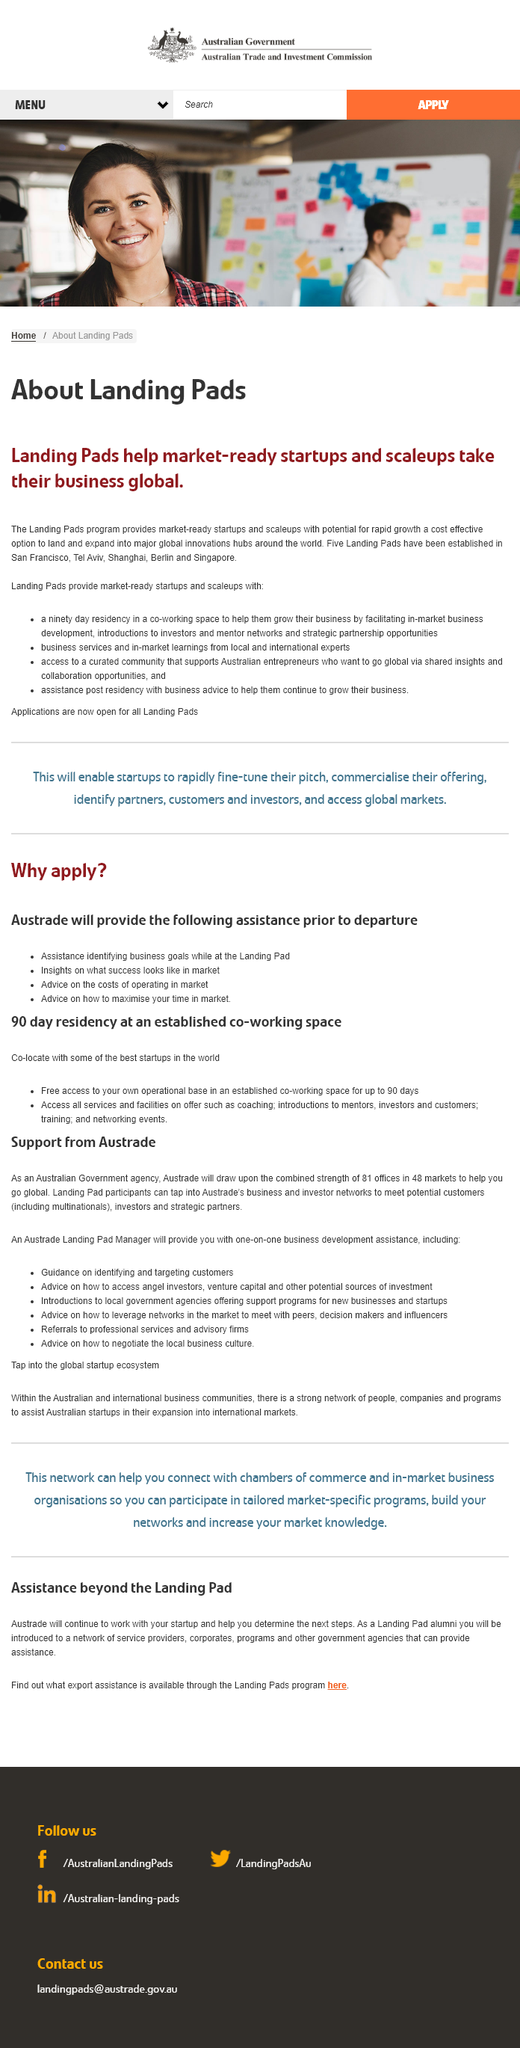Indicate a few pertinent items in this graphic. Landing Pads provides market-ready startups with a 90-day residency to support their growth and success. The support does not end after the residency. To date, a total of 5 landing pads have been established. 